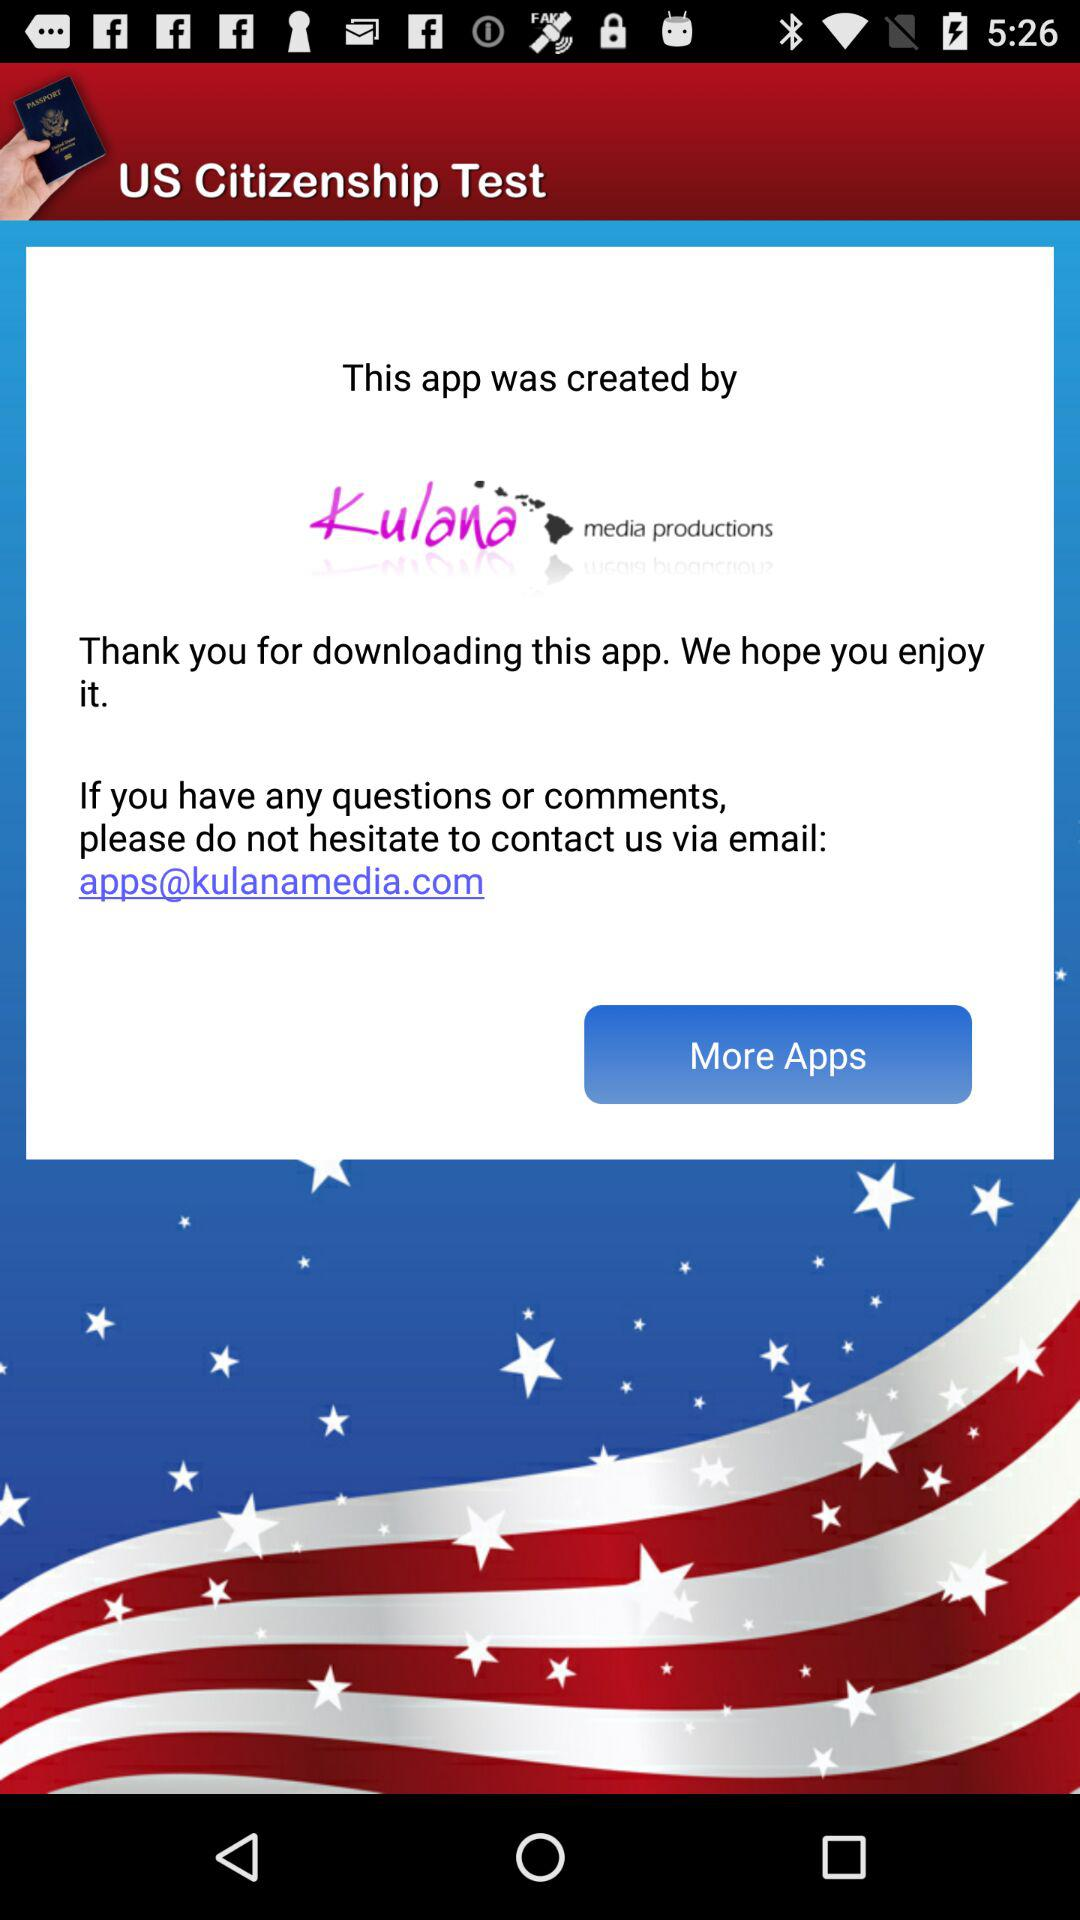What is the application name? The application name is "US Citizenship Test". 